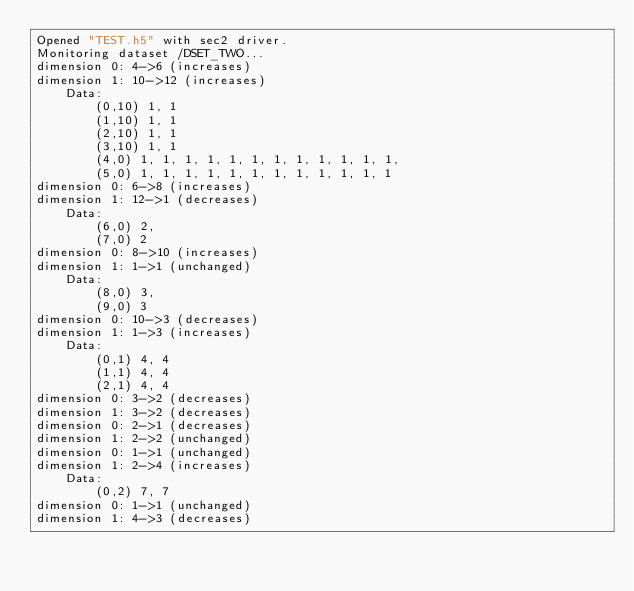<code> <loc_0><loc_0><loc_500><loc_500><_SQL_>Opened "TEST.h5" with sec2 driver.
Monitoring dataset /DSET_TWO...
dimension 0: 4->6 (increases)
dimension 1: 10->12 (increases)
    Data:
        (0,10) 1, 1
        (1,10) 1, 1
        (2,10) 1, 1
        (3,10) 1, 1
        (4,0) 1, 1, 1, 1, 1, 1, 1, 1, 1, 1, 1, 1,
        (5,0) 1, 1, 1, 1, 1, 1, 1, 1, 1, 1, 1, 1
dimension 0: 6->8 (increases)
dimension 1: 12->1 (decreases)
    Data:
        (6,0) 2,
        (7,0) 2
dimension 0: 8->10 (increases)
dimension 1: 1->1 (unchanged)
    Data:
        (8,0) 3,
        (9,0) 3
dimension 0: 10->3 (decreases)
dimension 1: 1->3 (increases)
    Data:
        (0,1) 4, 4
        (1,1) 4, 4
        (2,1) 4, 4
dimension 0: 3->2 (decreases)
dimension 1: 3->2 (decreases)
dimension 0: 2->1 (decreases)
dimension 1: 2->2 (unchanged)
dimension 0: 1->1 (unchanged)
dimension 1: 2->4 (increases)
    Data:
        (0,2) 7, 7
dimension 0: 1->1 (unchanged)
dimension 1: 4->3 (decreases)
</code> 